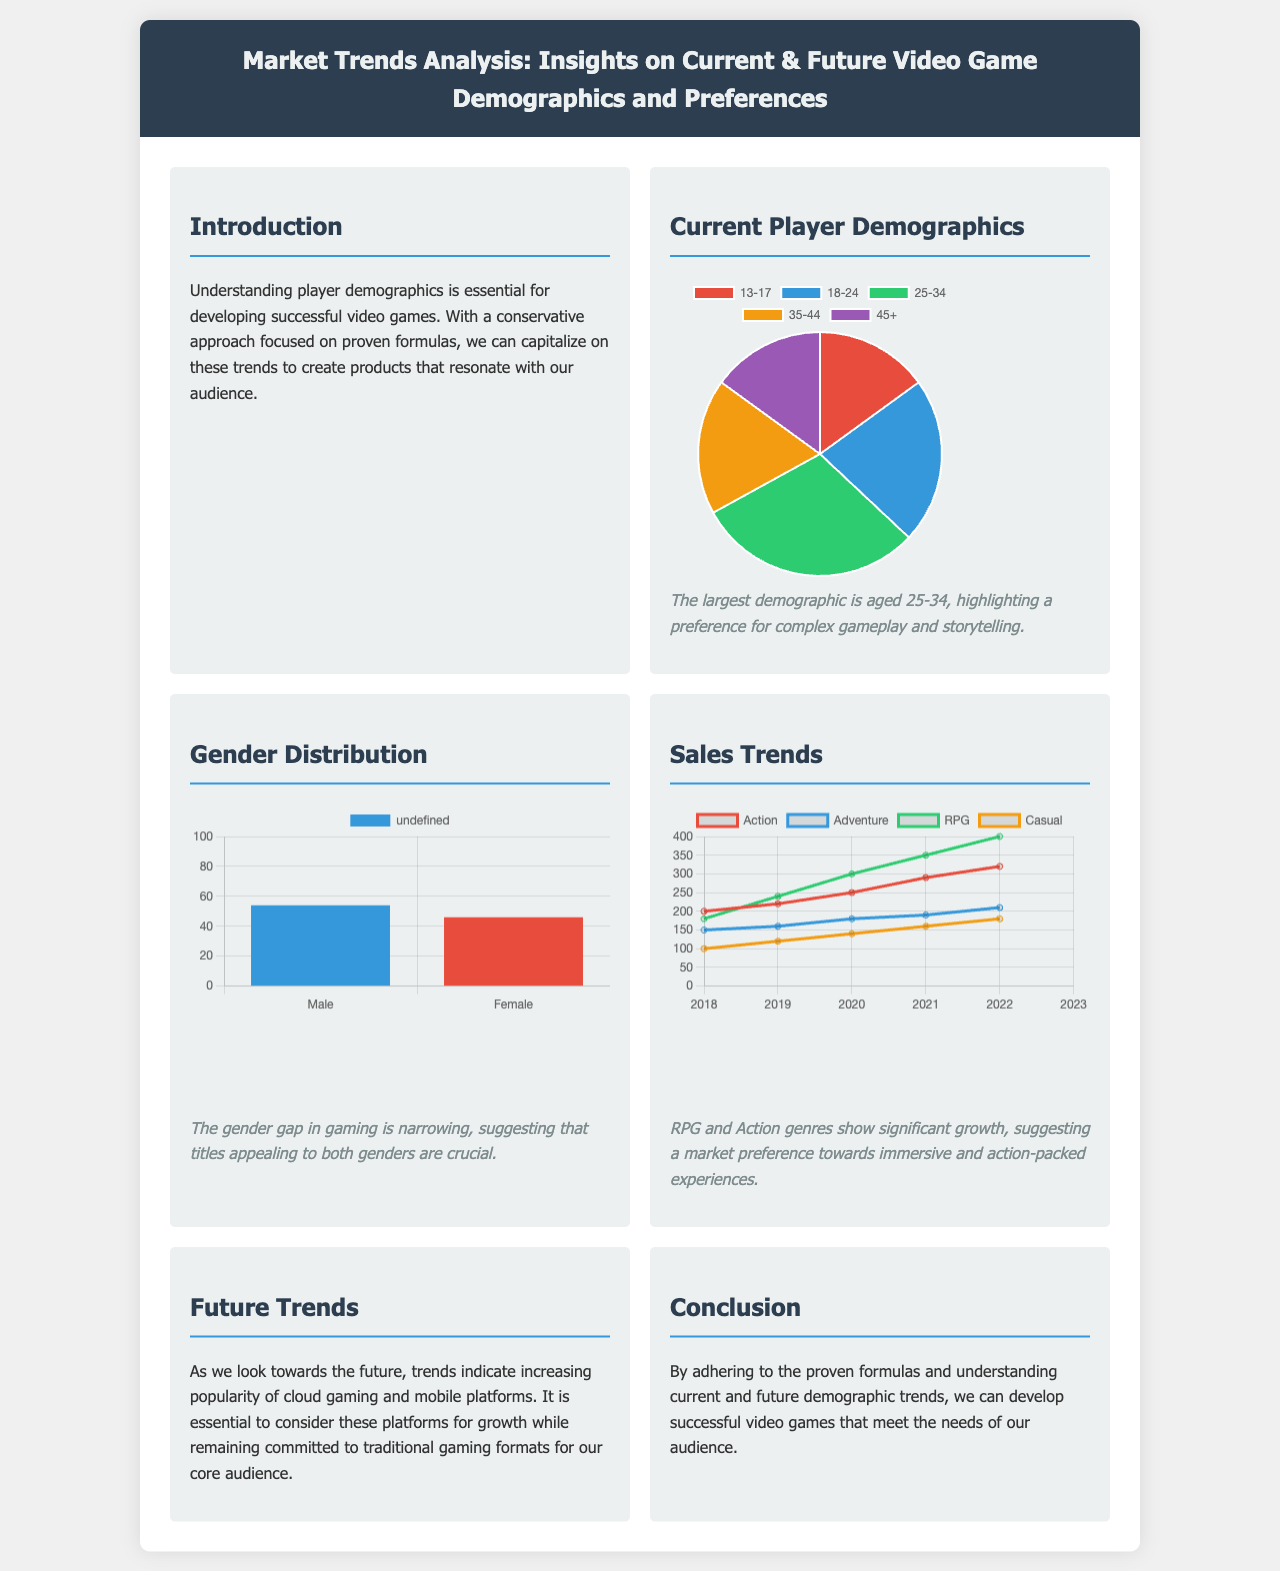What is the largest age demographic for video game players? The document states that the largest demographic is aged 25-34.
Answer: 25-34 What percentage of gamers are female? The gender chart indicates that 46% of gamers are female.
Answer: 46 Which genre shows the highest sales growth from 2018 to 2023? The RPG genre demonstrates the highest sales growth during this period, as indicated in the sales chart.
Answer: RPG What is the overall trend indicated for cloud gaming in the future? The document suggests that cloud gaming is increasingly popular moving forward.
Answer: Increasing popularity Which demographic age group accounts for the lowest percentage of gamers? According to the age distribution, the 13-17 age group accounts for the lowest percentage of gamers.
Answer: 13-17 What year marks the start of the sales trend analysis? The sales trend analysis starts from the year 2018, as mentioned in the document.
Answer: 2018 What two genres are highlighted as showing significant growth? The document notes significant growth in the RPG and Action genres based on sales trends.
Answer: RPG and Action What is the color representing male gamers in the gender distribution chart? The color representing male gamers is blue, as seen in the gender distribution chart.
Answer: Blue 